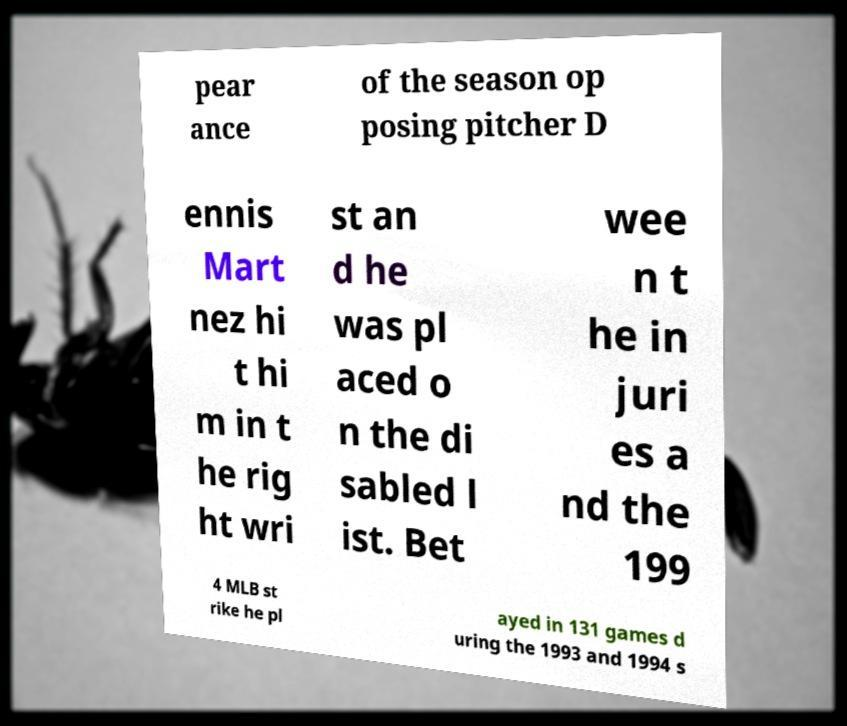I need the written content from this picture converted into text. Can you do that? pear ance of the season op posing pitcher D ennis Mart nez hi t hi m in t he rig ht wri st an d he was pl aced o n the di sabled l ist. Bet wee n t he in juri es a nd the 199 4 MLB st rike he pl ayed in 131 games d uring the 1993 and 1994 s 